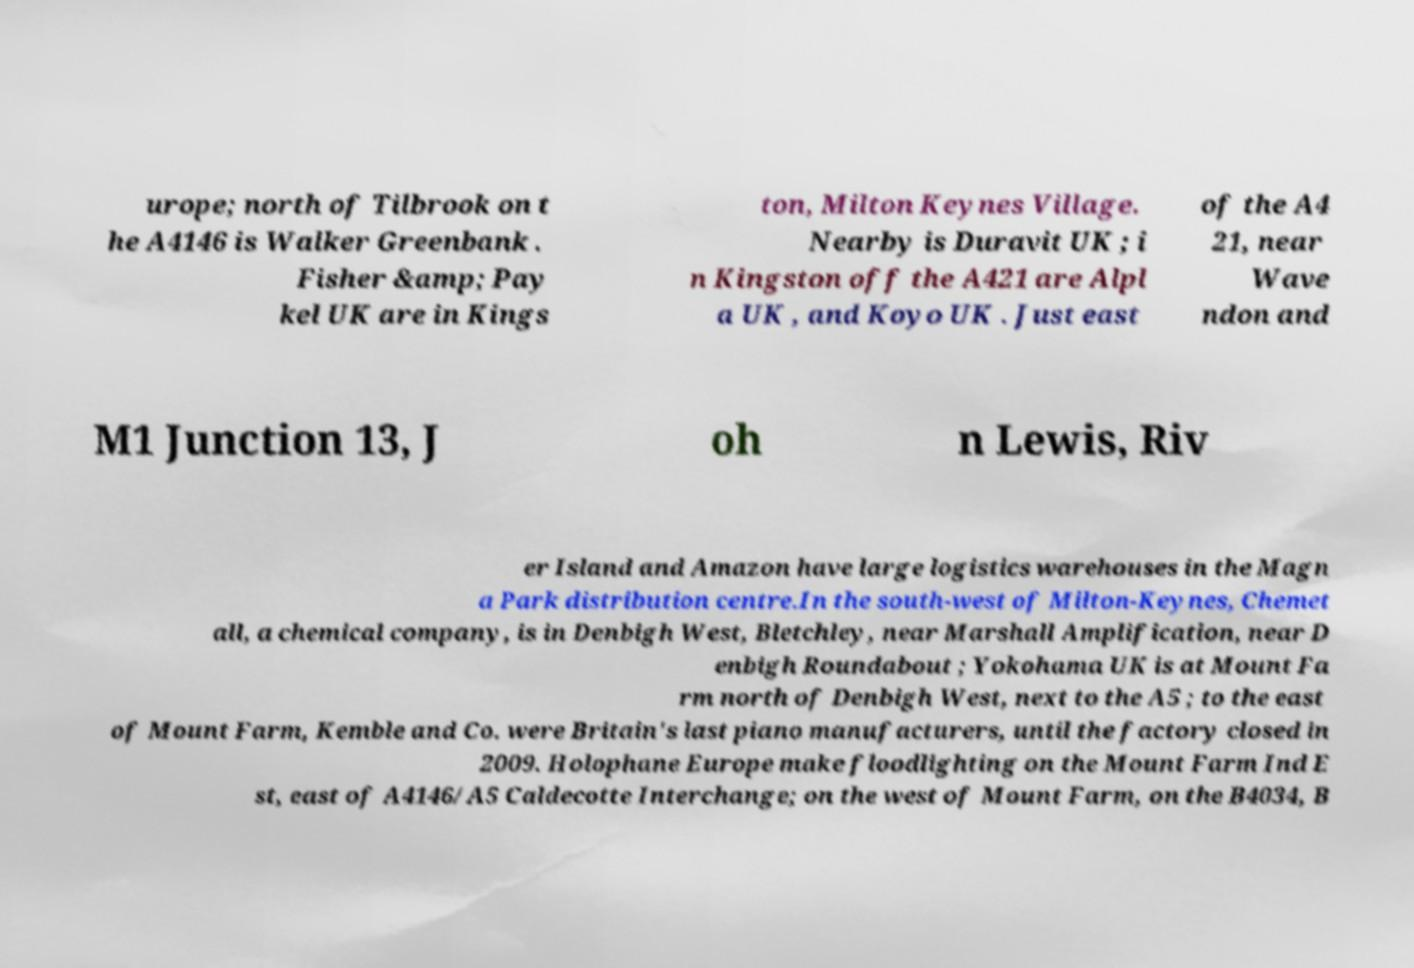Please read and relay the text visible in this image. What does it say? urope; north of Tilbrook on t he A4146 is Walker Greenbank . Fisher &amp; Pay kel UK are in Kings ton, Milton Keynes Village. Nearby is Duravit UK ; i n Kingston off the A421 are Alpl a UK , and Koyo UK . Just east of the A4 21, near Wave ndon and M1 Junction 13, J oh n Lewis, Riv er Island and Amazon have large logistics warehouses in the Magn a Park distribution centre.In the south-west of Milton-Keynes, Chemet all, a chemical company, is in Denbigh West, Bletchley, near Marshall Amplification, near D enbigh Roundabout ; Yokohama UK is at Mount Fa rm north of Denbigh West, next to the A5 ; to the east of Mount Farm, Kemble and Co. were Britain's last piano manufacturers, until the factory closed in 2009. Holophane Europe make floodlighting on the Mount Farm Ind E st, east of A4146/A5 Caldecotte Interchange; on the west of Mount Farm, on the B4034, B 